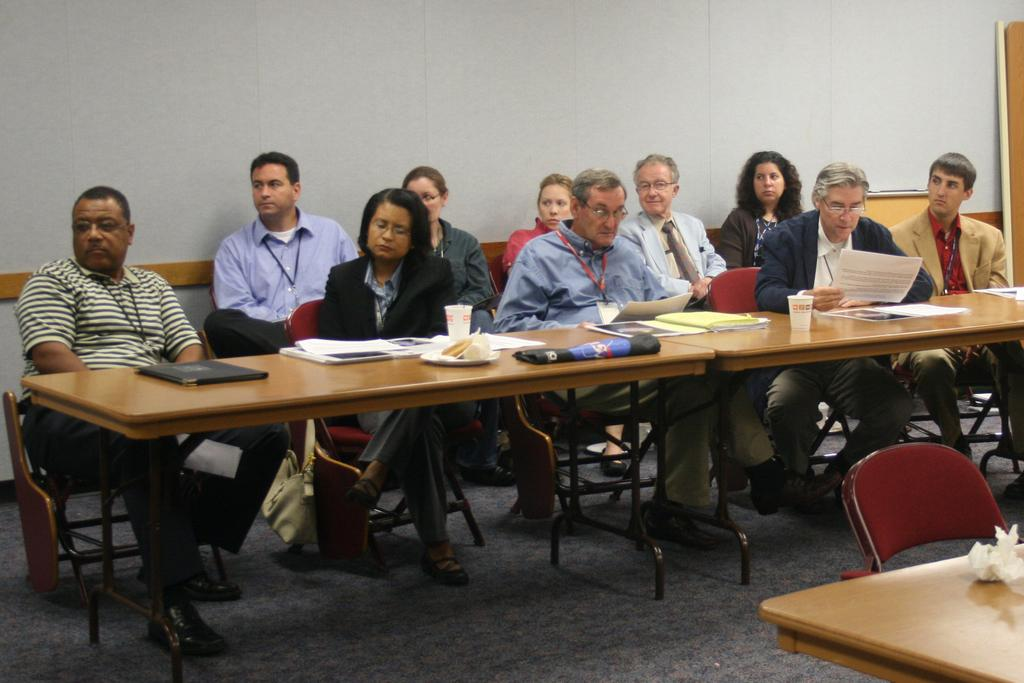How many people are in the image? There are many people in the image. What are the people doing in the image? The people are sitting on chairs. Where are the chairs located in relation to the table? The chairs are in front of a table. What type of setting does the image appear to depict? The setting appears to be a meeting room. What type of pest can be seen crawling on the table in the image? There is no pest visible on the table in the image. Is there a crook present in the image, and if so, what is he doing? There is no crook present in the image; it depicts a meeting room with people sitting on chairs in front of a table. 